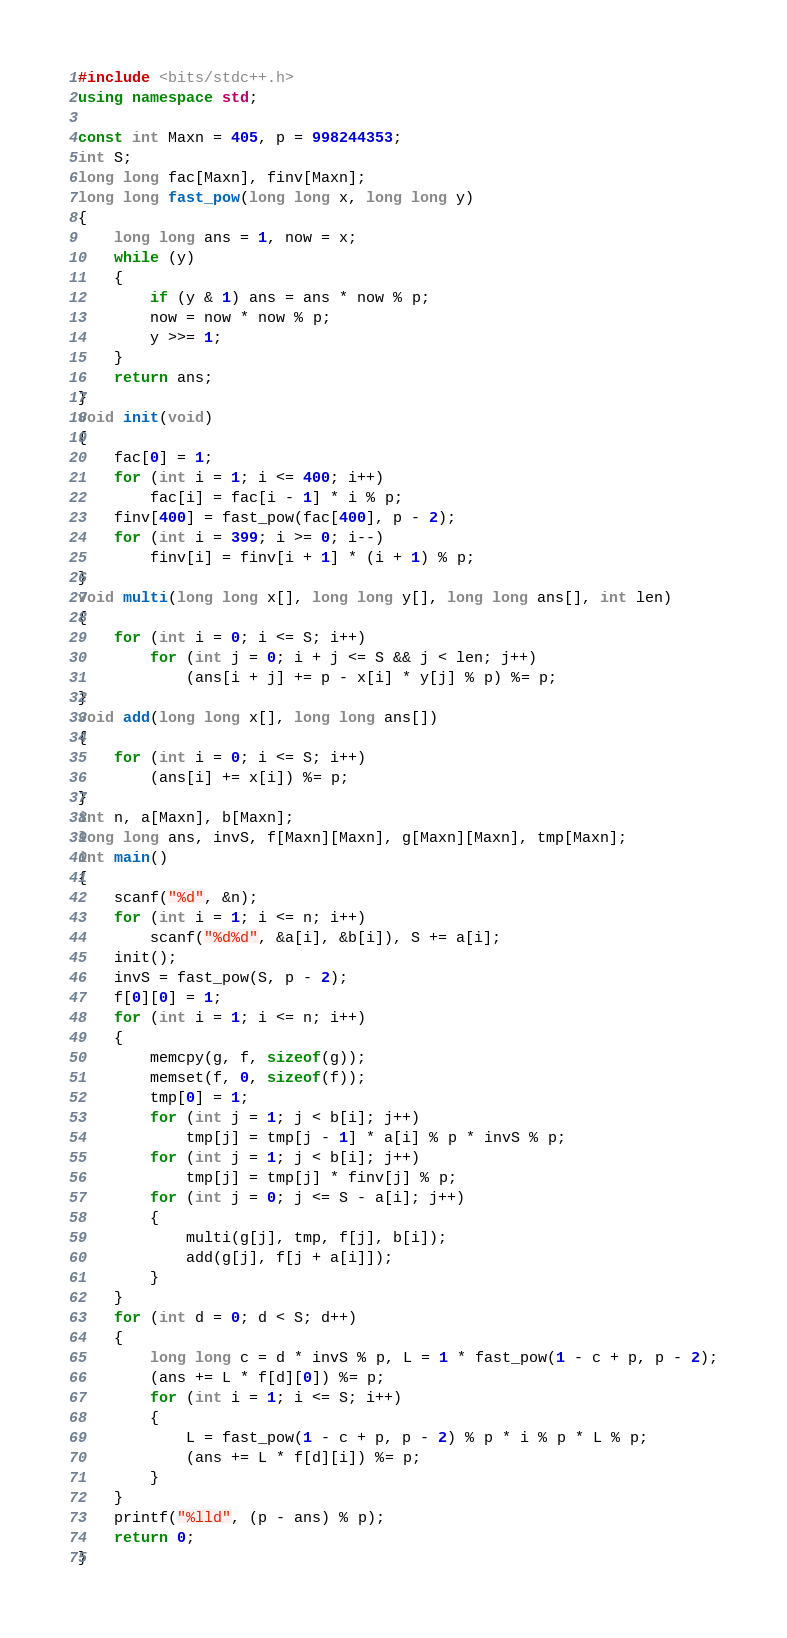<code> <loc_0><loc_0><loc_500><loc_500><_C++_>#include <bits/stdc++.h>
using namespace std;

const int Maxn = 405, p = 998244353;
int S;
long long fac[Maxn], finv[Maxn];
long long fast_pow(long long x, long long y)
{
	long long ans = 1, now = x;
	while (y)
	{
		if (y & 1) ans = ans * now % p;
		now = now * now % p;
		y >>= 1;
	}
	return ans;
}
void init(void)
{
	fac[0] = 1;
	for (int i = 1; i <= 400; i++)
		fac[i] = fac[i - 1] * i % p;
	finv[400] = fast_pow(fac[400], p - 2);
	for (int i = 399; i >= 0; i--)
		finv[i] = finv[i + 1] * (i + 1) % p;
}
void multi(long long x[], long long y[], long long ans[], int len)
{
	for (int i = 0; i <= S; i++)
		for (int j = 0; i + j <= S && j < len; j++)
			(ans[i + j] += p - x[i] * y[j] % p) %= p;
}
void add(long long x[], long long ans[])
{
	for (int i = 0; i <= S; i++)
		(ans[i] += x[i]) %= p;
}
int n, a[Maxn], b[Maxn];
long long ans, invS, f[Maxn][Maxn], g[Maxn][Maxn], tmp[Maxn];
int main()
{
	scanf("%d", &n);
	for (int i = 1; i <= n; i++)
		scanf("%d%d", &a[i], &b[i]), S += a[i];
	init();
	invS = fast_pow(S, p - 2);
	f[0][0] = 1;
	for (int i = 1; i <= n; i++)
	{
		memcpy(g, f, sizeof(g));
		memset(f, 0, sizeof(f));
		tmp[0] = 1;
		for (int j = 1; j < b[i]; j++)
			tmp[j] = tmp[j - 1] * a[i] % p * invS % p;
		for (int j = 1; j < b[i]; j++)
			tmp[j] = tmp[j] * finv[j] % p;
		for (int j = 0; j <= S - a[i]; j++)
		{
			multi(g[j], tmp, f[j], b[i]);
			add(g[j], f[j + a[i]]);
		}
	}
	for (int d = 0; d < S; d++)
	{
		long long c = d * invS % p, L = 1 * fast_pow(1 - c + p, p - 2);
		(ans += L * f[d][0]) %= p;
		for (int i = 1; i <= S; i++)
		{
			L = fast_pow(1 - c + p, p - 2) % p * i % p * L % p;
			(ans += L * f[d][i]) %= p;
		}
	}
	printf("%lld", (p - ans) % p);
	return 0;
}</code> 